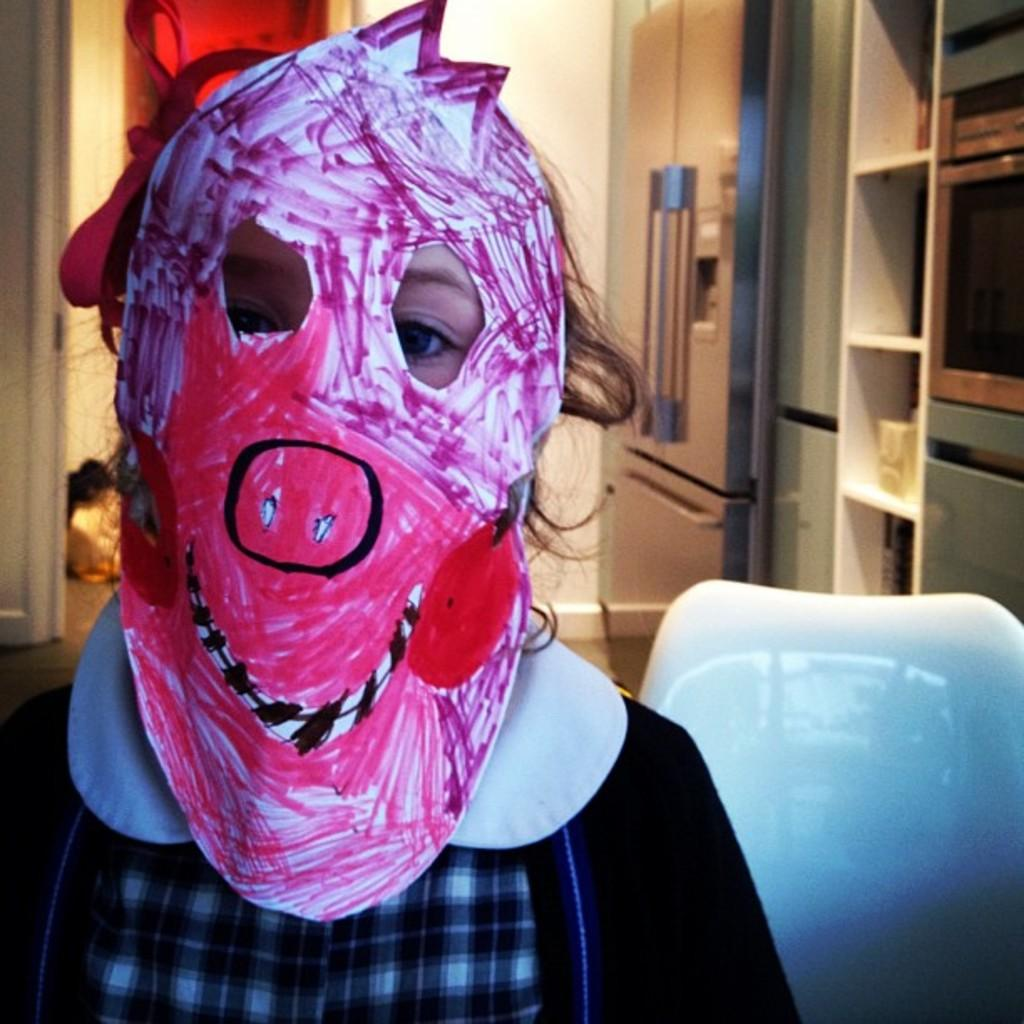What can be seen in the image? There is a person in the image, along with a chair, refrigerator, shelf, floor, and wall. What is the person wearing? The person is wearing clothes and a face mask. Can you describe the furniture in the image? There is a chair and a shelf in the image. What type of surface is present in the image? There is a floor in the image. What is the background of the image? There is a wall in the image. What type of pen is the person using to write on the map in the image? There is no pen or map present in the image. 